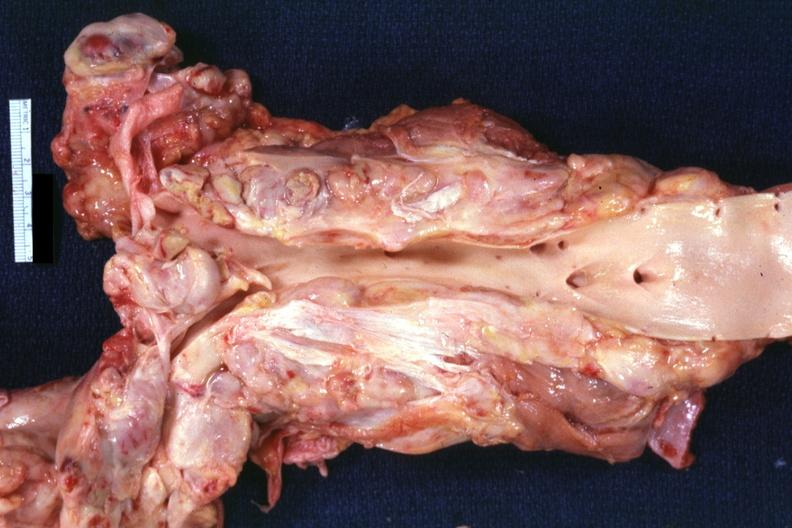what is present?
Answer the question using a single word or phrase. Hodgkins disease 